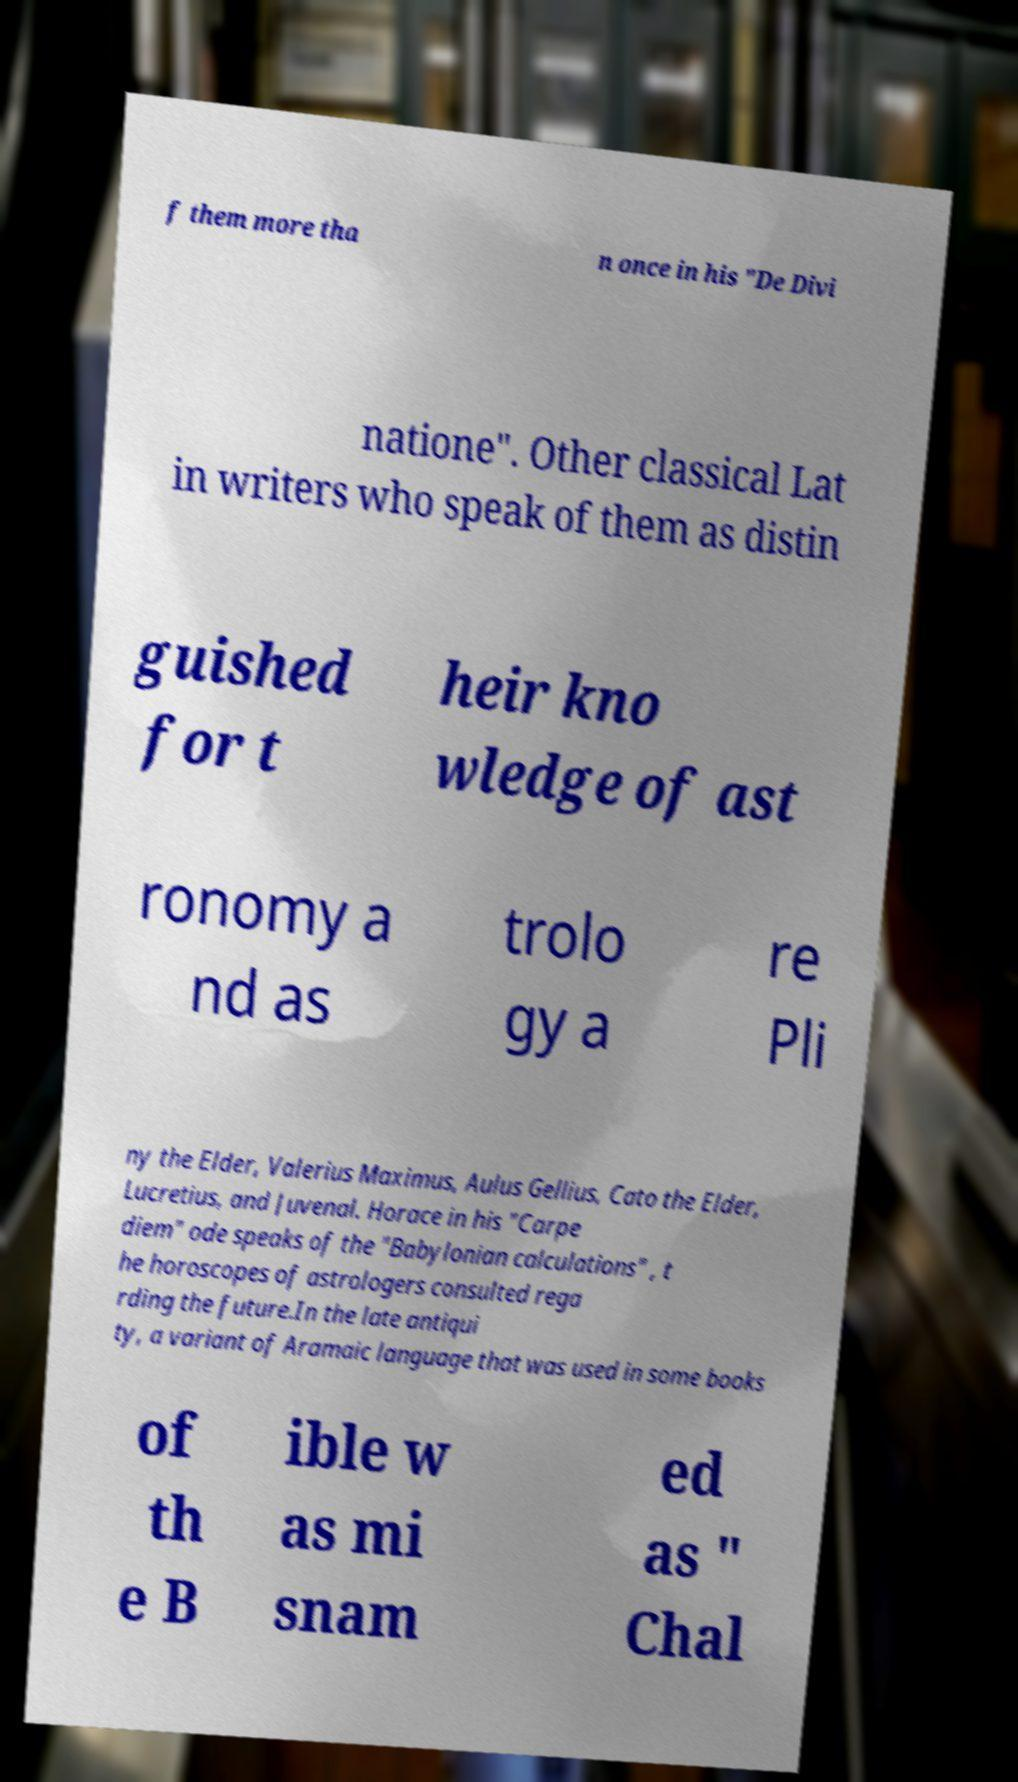Can you read and provide the text displayed in the image?This photo seems to have some interesting text. Can you extract and type it out for me? f them more tha n once in his "De Divi natione". Other classical Lat in writers who speak of them as distin guished for t heir kno wledge of ast ronomy a nd as trolo gy a re Pli ny the Elder, Valerius Maximus, Aulus Gellius, Cato the Elder, Lucretius, and Juvenal. Horace in his "Carpe diem" ode speaks of the "Babylonian calculations" , t he horoscopes of astrologers consulted rega rding the future.In the late antiqui ty, a variant of Aramaic language that was used in some books of th e B ible w as mi snam ed as " Chal 